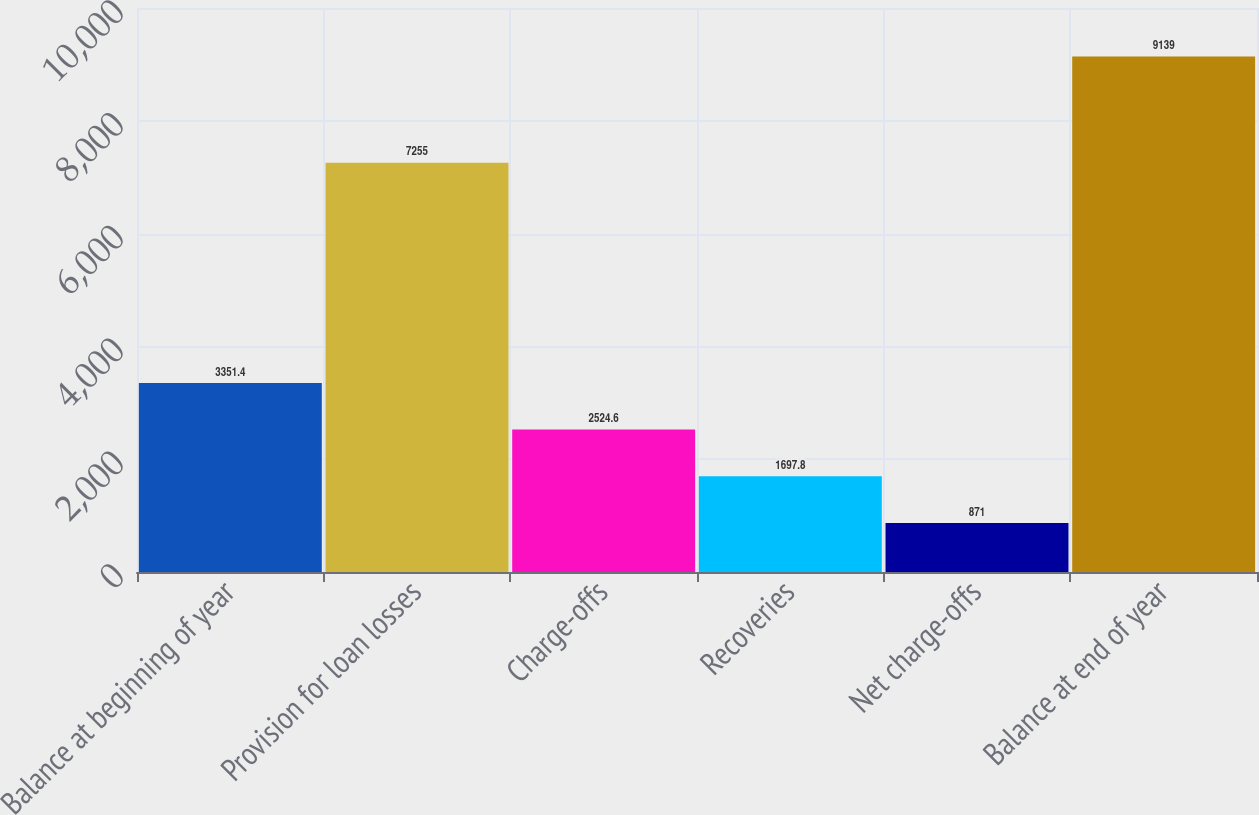Convert chart. <chart><loc_0><loc_0><loc_500><loc_500><bar_chart><fcel>Balance at beginning of year<fcel>Provision for loan losses<fcel>Charge-offs<fcel>Recoveries<fcel>Net charge-offs<fcel>Balance at end of year<nl><fcel>3351.4<fcel>7255<fcel>2524.6<fcel>1697.8<fcel>871<fcel>9139<nl></chart> 